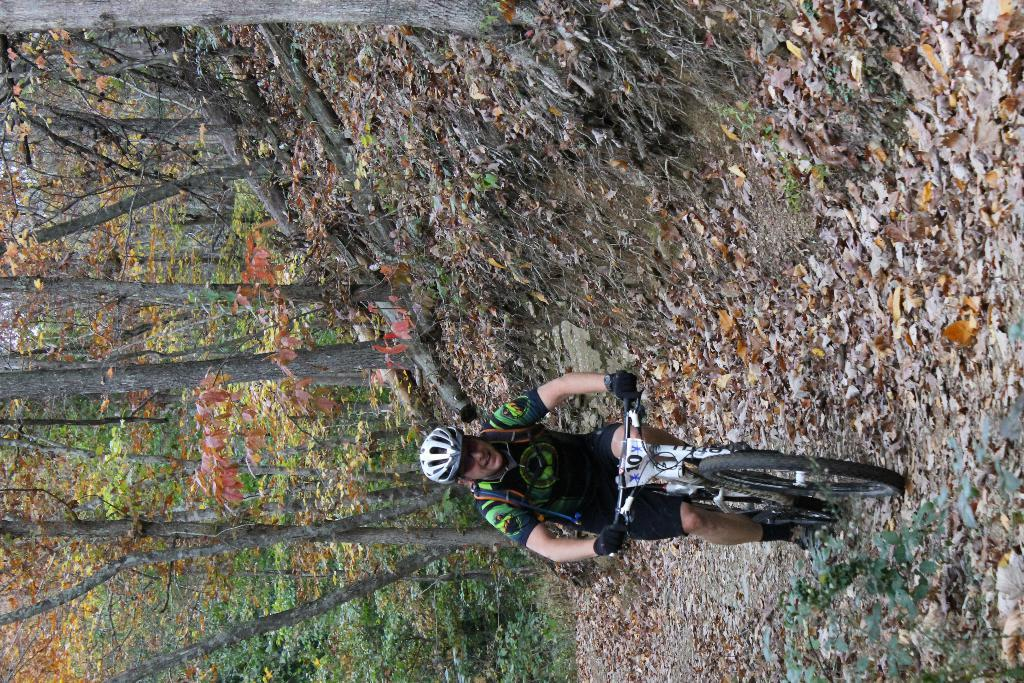Who is the person in the image? There is a man in the image. What is the man doing in the image? The man is riding a bicycle. What can be seen on the ground in the image? There are dried leaves in the image. What type of vegetation is present in the image? There are trees and plants in the image. What color is the ink used to write the man's name on the bicycle? There is no indication in the image that the man's name is written on the bicycle, and therefore no ink color can be determined. 